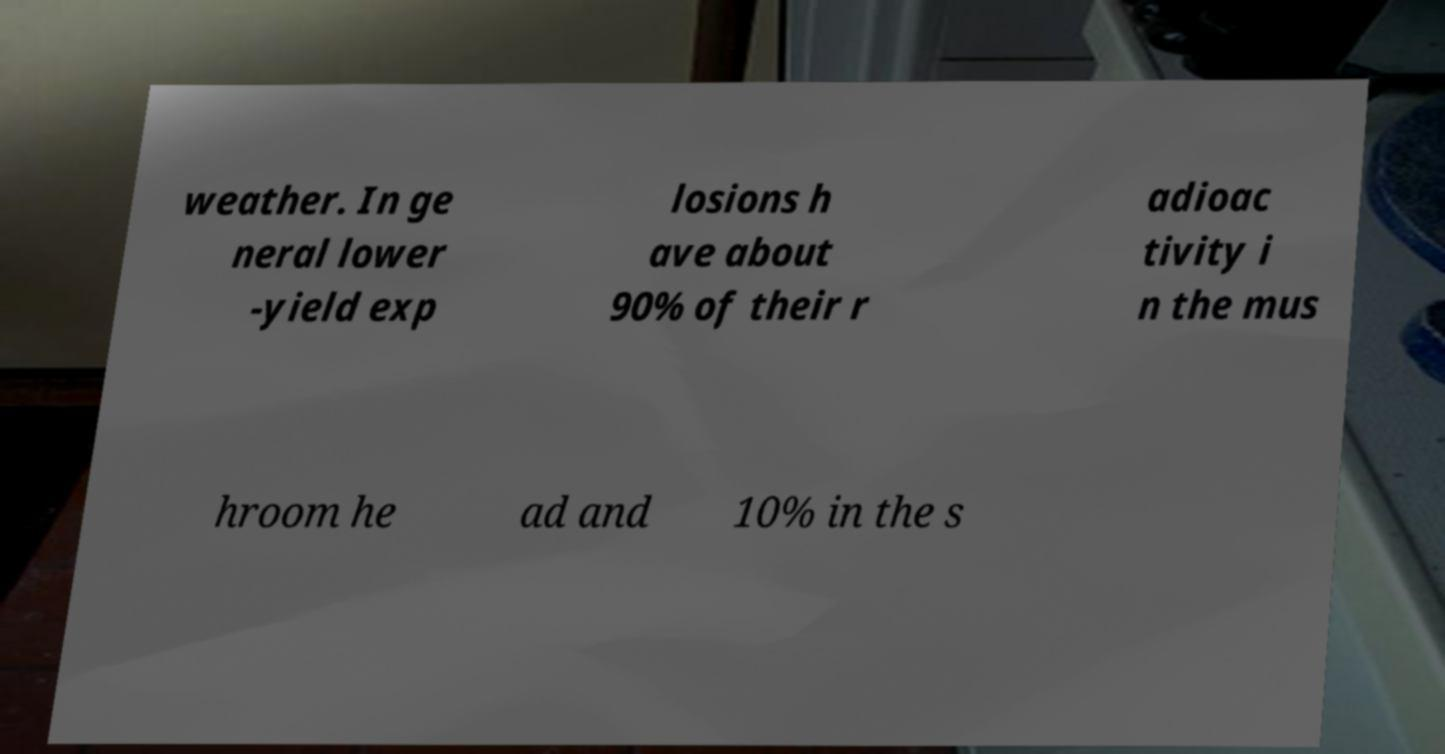For documentation purposes, I need the text within this image transcribed. Could you provide that? weather. In ge neral lower -yield exp losions h ave about 90% of their r adioac tivity i n the mus hroom he ad and 10% in the s 